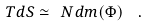<formula> <loc_0><loc_0><loc_500><loc_500>T d S \simeq \ N d m ( \Phi ) \ \ .</formula> 